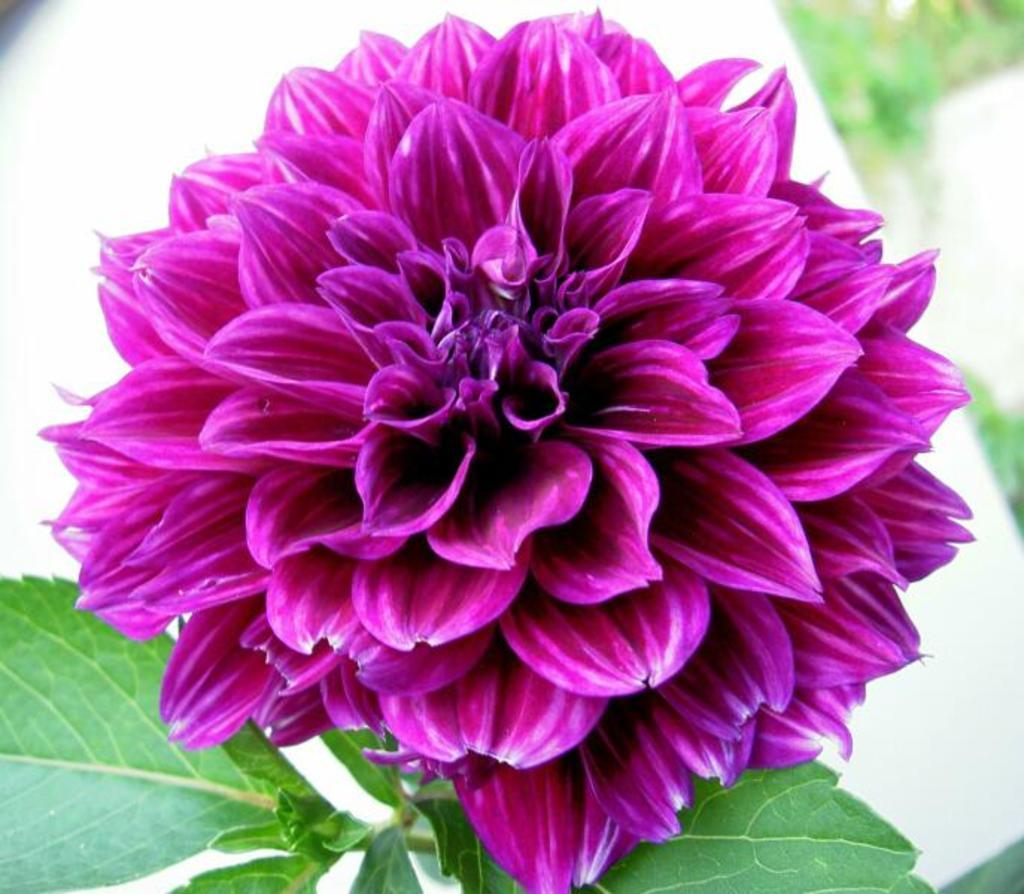What type of plant can be seen in the image? There is a flower in the image. Are there any other plants visible in the image? Yes, there are plants in the image. Can you describe the background of the image? The background of the image is blurred. What type of fuel is being used by the star in the image? There is no star present in the image, and therefore no fuel can be associated with it. 